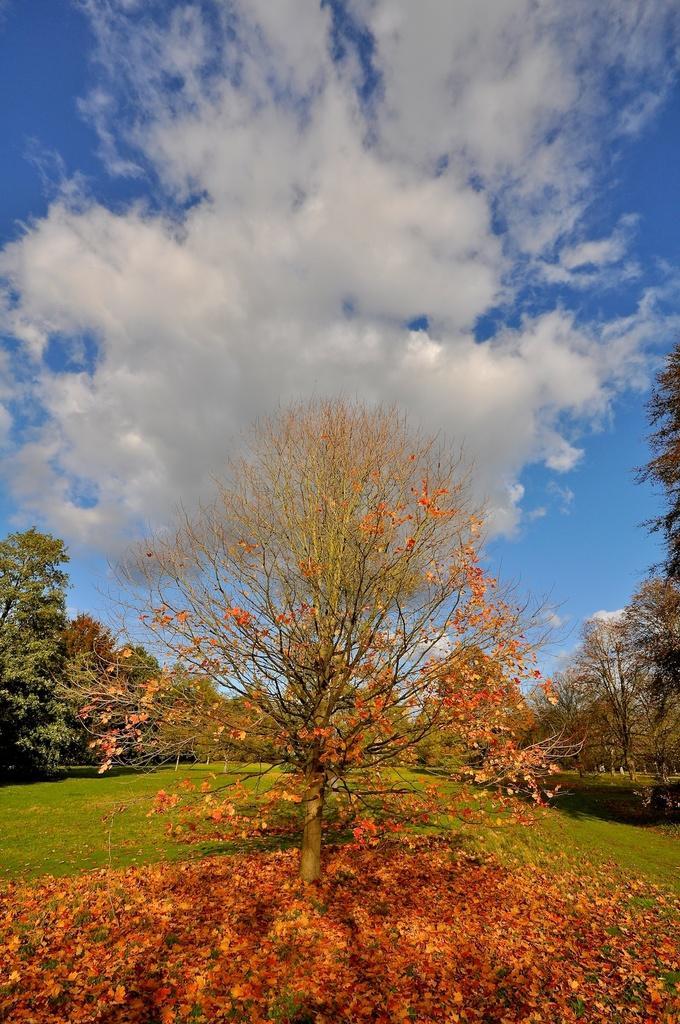Could you give a brief overview of what you see in this image? In this picture we can see a few trees and some leaves on the ground. There is some grass on the ground. Sky is blue in color and cloudy. 